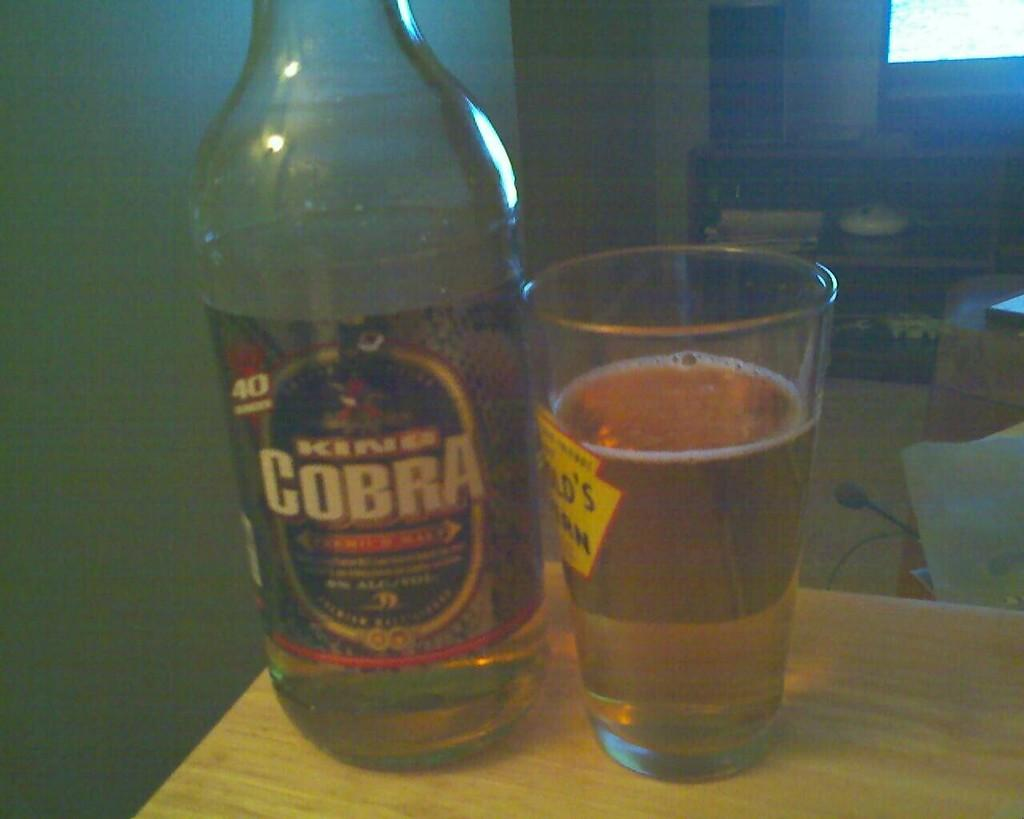What type of beverage is present in the image? There is beer in the image, both in a bottle and a tumbler. Where are the beer bottle and tumbler located? Both the beer bottle and tumbler are placed on a table. What can be seen in the background of the image? There is a rack visible in the background of the image. What is inside the rack? There are objects placed inside the rack. What type of apple is being used as lumber in the image? There is no apple or lumber present in the image. How does the behavior of the beer change throughout the image? The behavior of the beer does not change throughout the image, as it remains stationary in the bottle and tumbler. 